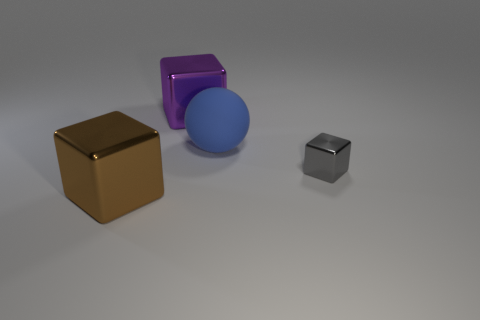Subtract all big metallic cubes. How many cubes are left? 1 Add 4 small green rubber spheres. How many objects exist? 8 Subtract 1 gray blocks. How many objects are left? 3 Subtract all cubes. How many objects are left? 1 Subtract all big blue spheres. Subtract all large metal blocks. How many objects are left? 1 Add 3 big purple shiny blocks. How many big purple shiny blocks are left? 4 Add 4 tiny cyan cylinders. How many tiny cyan cylinders exist? 4 